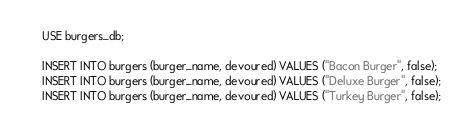<code> <loc_0><loc_0><loc_500><loc_500><_SQL_>USE burgers_db;

INSERT INTO burgers (burger_name, devoured) VALUES ("Bacon Burger", false);
INSERT INTO burgers (burger_name, devoured) VALUES ("Deluxe Burger", false);
INSERT INTO burgers (burger_name, devoured) VALUES ("Turkey Burger", false);</code> 